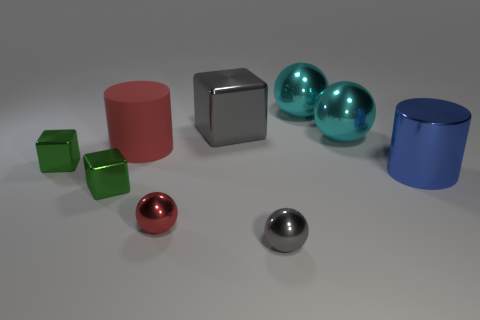There is another small thing that is the same shape as the small red object; what is it made of?
Offer a very short reply. Metal. Is the shape of the gray thing that is behind the big matte object the same as  the big red object?
Your answer should be compact. No. Is there anything else that is the same size as the red cylinder?
Ensure brevity in your answer.  Yes. Are there fewer red cylinders to the left of the red shiny sphere than metal cylinders on the left side of the large gray metal thing?
Offer a very short reply. No. What number of other things are the same shape as the large blue thing?
Keep it short and to the point. 1. There is a metallic thing to the right of the cyan metallic ball that is in front of the large shiny thing left of the tiny gray ball; what is its size?
Provide a succinct answer. Large. How many yellow things are either cylinders or rubber cylinders?
Your answer should be very brief. 0. There is a thing to the left of the green object that is in front of the metal cylinder; what shape is it?
Your answer should be very brief. Cube. There is a cube in front of the blue cylinder; does it have the same size as the gray object that is in front of the big metal cylinder?
Your response must be concise. Yes. Is there another tiny gray ball made of the same material as the tiny gray ball?
Offer a very short reply. No. 